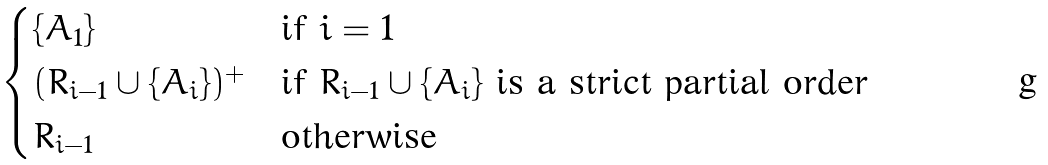Convert formula to latex. <formula><loc_0><loc_0><loc_500><loc_500>\begin{cases} \{ { A _ { 1 } } \} & \text {if } { i = 1 } \\ ( R _ { i - 1 } \cup \{ { A _ { i } } \} ) ^ { + } & \text {if } R _ { i - 1 } \cup \{ { A _ { i } } \} \ \text {is a strict partial order} \\ R _ { i - 1 } & \text {otherwise} \end{cases}</formula> 